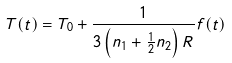Convert formula to latex. <formula><loc_0><loc_0><loc_500><loc_500>T ( t ) = T _ { 0 } + \frac { 1 } { 3 \left ( n _ { 1 } + \frac { 1 } { 2 } n _ { 2 } \right ) R } f ( t )</formula> 